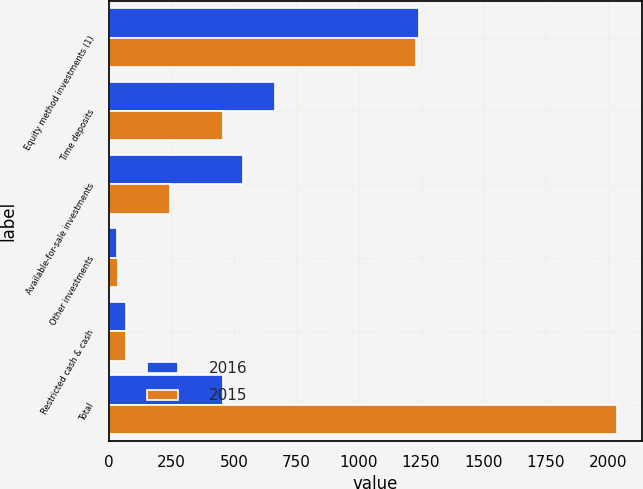Convert chart. <chart><loc_0><loc_0><loc_500><loc_500><stacked_bar_chart><ecel><fcel>Equity method investments (1)<fcel>Time deposits<fcel>Available-for-sale investments<fcel>Other investments<fcel>Restricted cash & cash<fcel>Total<nl><fcel>2016<fcel>1242<fcel>665<fcel>537<fcel>33<fcel>68<fcel>456<nl><fcel>2015<fcel>1230<fcel>456<fcel>244<fcel>35<fcel>69<fcel>2034<nl></chart> 